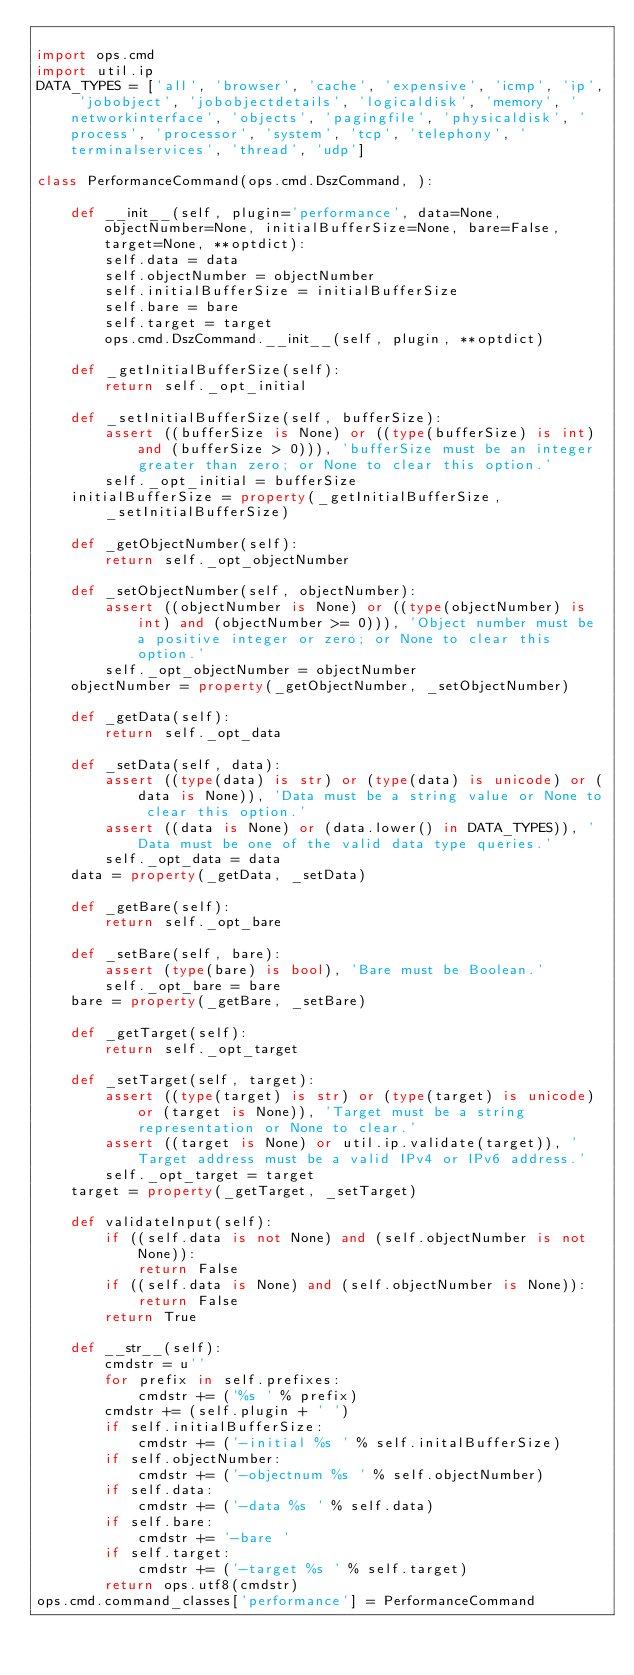<code> <loc_0><loc_0><loc_500><loc_500><_Python_>
import ops.cmd
import util.ip
DATA_TYPES = ['all', 'browser', 'cache', 'expensive', 'icmp', 'ip', 'jobobject', 'jobobjectdetails', 'logicaldisk', 'memory', 'networkinterface', 'objects', 'pagingfile', 'physicaldisk', 'process', 'processor', 'system', 'tcp', 'telephony', 'terminalservices', 'thread', 'udp']

class PerformanceCommand(ops.cmd.DszCommand, ):

    def __init__(self, plugin='performance', data=None, objectNumber=None, initialBufferSize=None, bare=False, target=None, **optdict):
        self.data = data
        self.objectNumber = objectNumber
        self.initialBufferSize = initialBufferSize
        self.bare = bare
        self.target = target
        ops.cmd.DszCommand.__init__(self, plugin, **optdict)

    def _getInitialBufferSize(self):
        return self._opt_initial

    def _setInitialBufferSize(self, bufferSize):
        assert ((bufferSize is None) or ((type(bufferSize) is int) and (bufferSize > 0))), 'bufferSize must be an integer greater than zero; or None to clear this option.'
        self._opt_initial = bufferSize
    initialBufferSize = property(_getInitialBufferSize, _setInitialBufferSize)

    def _getObjectNumber(self):
        return self._opt_objectNumber

    def _setObjectNumber(self, objectNumber):
        assert ((objectNumber is None) or ((type(objectNumber) is int) and (objectNumber >= 0))), 'Object number must be a positive integer or zero; or None to clear this option.'
        self._opt_objectNumber = objectNumber
    objectNumber = property(_getObjectNumber, _setObjectNumber)

    def _getData(self):
        return self._opt_data

    def _setData(self, data):
        assert ((type(data) is str) or (type(data) is unicode) or (data is None)), 'Data must be a string value or None to clear this option.'
        assert ((data is None) or (data.lower() in DATA_TYPES)), 'Data must be one of the valid data type queries.'
        self._opt_data = data
    data = property(_getData, _setData)

    def _getBare(self):
        return self._opt_bare

    def _setBare(self, bare):
        assert (type(bare) is bool), 'Bare must be Boolean.'
        self._opt_bare = bare
    bare = property(_getBare, _setBare)

    def _getTarget(self):
        return self._opt_target

    def _setTarget(self, target):
        assert ((type(target) is str) or (type(target) is unicode) or (target is None)), 'Target must be a string representation or None to clear.'
        assert ((target is None) or util.ip.validate(target)), 'Target address must be a valid IPv4 or IPv6 address.'
        self._opt_target = target
    target = property(_getTarget, _setTarget)

    def validateInput(self):
        if ((self.data is not None) and (self.objectNumber is not None)):
            return False
        if ((self.data is None) and (self.objectNumber is None)):
            return False
        return True

    def __str__(self):
        cmdstr = u''
        for prefix in self.prefixes:
            cmdstr += ('%s ' % prefix)
        cmdstr += (self.plugin + ' ')
        if self.initialBufferSize:
            cmdstr += ('-initial %s ' % self.initalBufferSize)
        if self.objectNumber:
            cmdstr += ('-objectnum %s ' % self.objectNumber)
        if self.data:
            cmdstr += ('-data %s ' % self.data)
        if self.bare:
            cmdstr += '-bare '
        if self.target:
            cmdstr += ('-target %s ' % self.target)
        return ops.utf8(cmdstr)
ops.cmd.command_classes['performance'] = PerformanceCommand</code> 